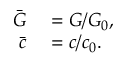Convert formula to latex. <formula><loc_0><loc_0><loc_500><loc_500>\begin{array} { r l } { \bar { G } } & = G / G _ { 0 } , } \\ { \bar { c } } & = c / c _ { 0 } . } \end{array}</formula> 